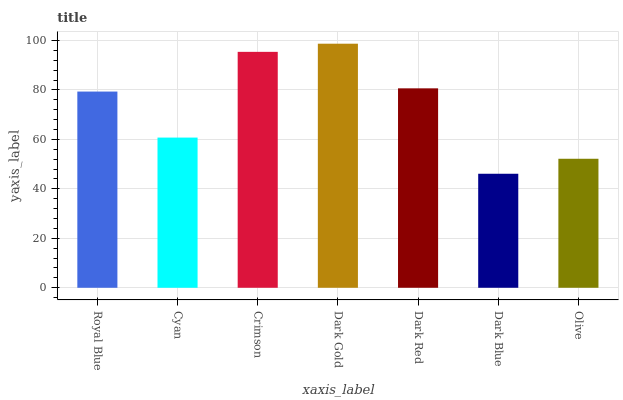Is Dark Blue the minimum?
Answer yes or no. Yes. Is Dark Gold the maximum?
Answer yes or no. Yes. Is Cyan the minimum?
Answer yes or no. No. Is Cyan the maximum?
Answer yes or no. No. Is Royal Blue greater than Cyan?
Answer yes or no. Yes. Is Cyan less than Royal Blue?
Answer yes or no. Yes. Is Cyan greater than Royal Blue?
Answer yes or no. No. Is Royal Blue less than Cyan?
Answer yes or no. No. Is Royal Blue the high median?
Answer yes or no. Yes. Is Royal Blue the low median?
Answer yes or no. Yes. Is Olive the high median?
Answer yes or no. No. Is Cyan the low median?
Answer yes or no. No. 